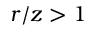Convert formula to latex. <formula><loc_0><loc_0><loc_500><loc_500>r / z > 1</formula> 